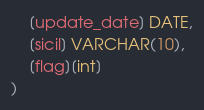Convert code to text. <code><loc_0><loc_0><loc_500><loc_500><_SQL_>	[update_date] DATE,
	[sicil] VARCHAR(10),
	[flag][int]
)
</code> 